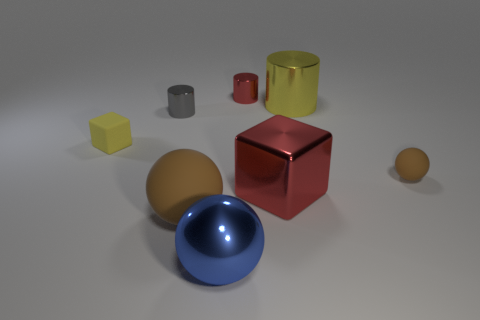Subtract all red cylinders. How many cylinders are left? 2 Subtract all green cylinders. How many brown balls are left? 2 Add 2 big yellow metal cubes. How many objects exist? 10 Subtract 1 balls. How many balls are left? 2 Subtract all balls. How many objects are left? 5 Subtract all cyan balls. Subtract all yellow blocks. How many balls are left? 3 Add 8 large yellow cylinders. How many large yellow cylinders exist? 9 Subtract 0 gray cubes. How many objects are left? 8 Subtract all tiny matte cylinders. Subtract all tiny gray metallic objects. How many objects are left? 7 Add 3 large things. How many large things are left? 7 